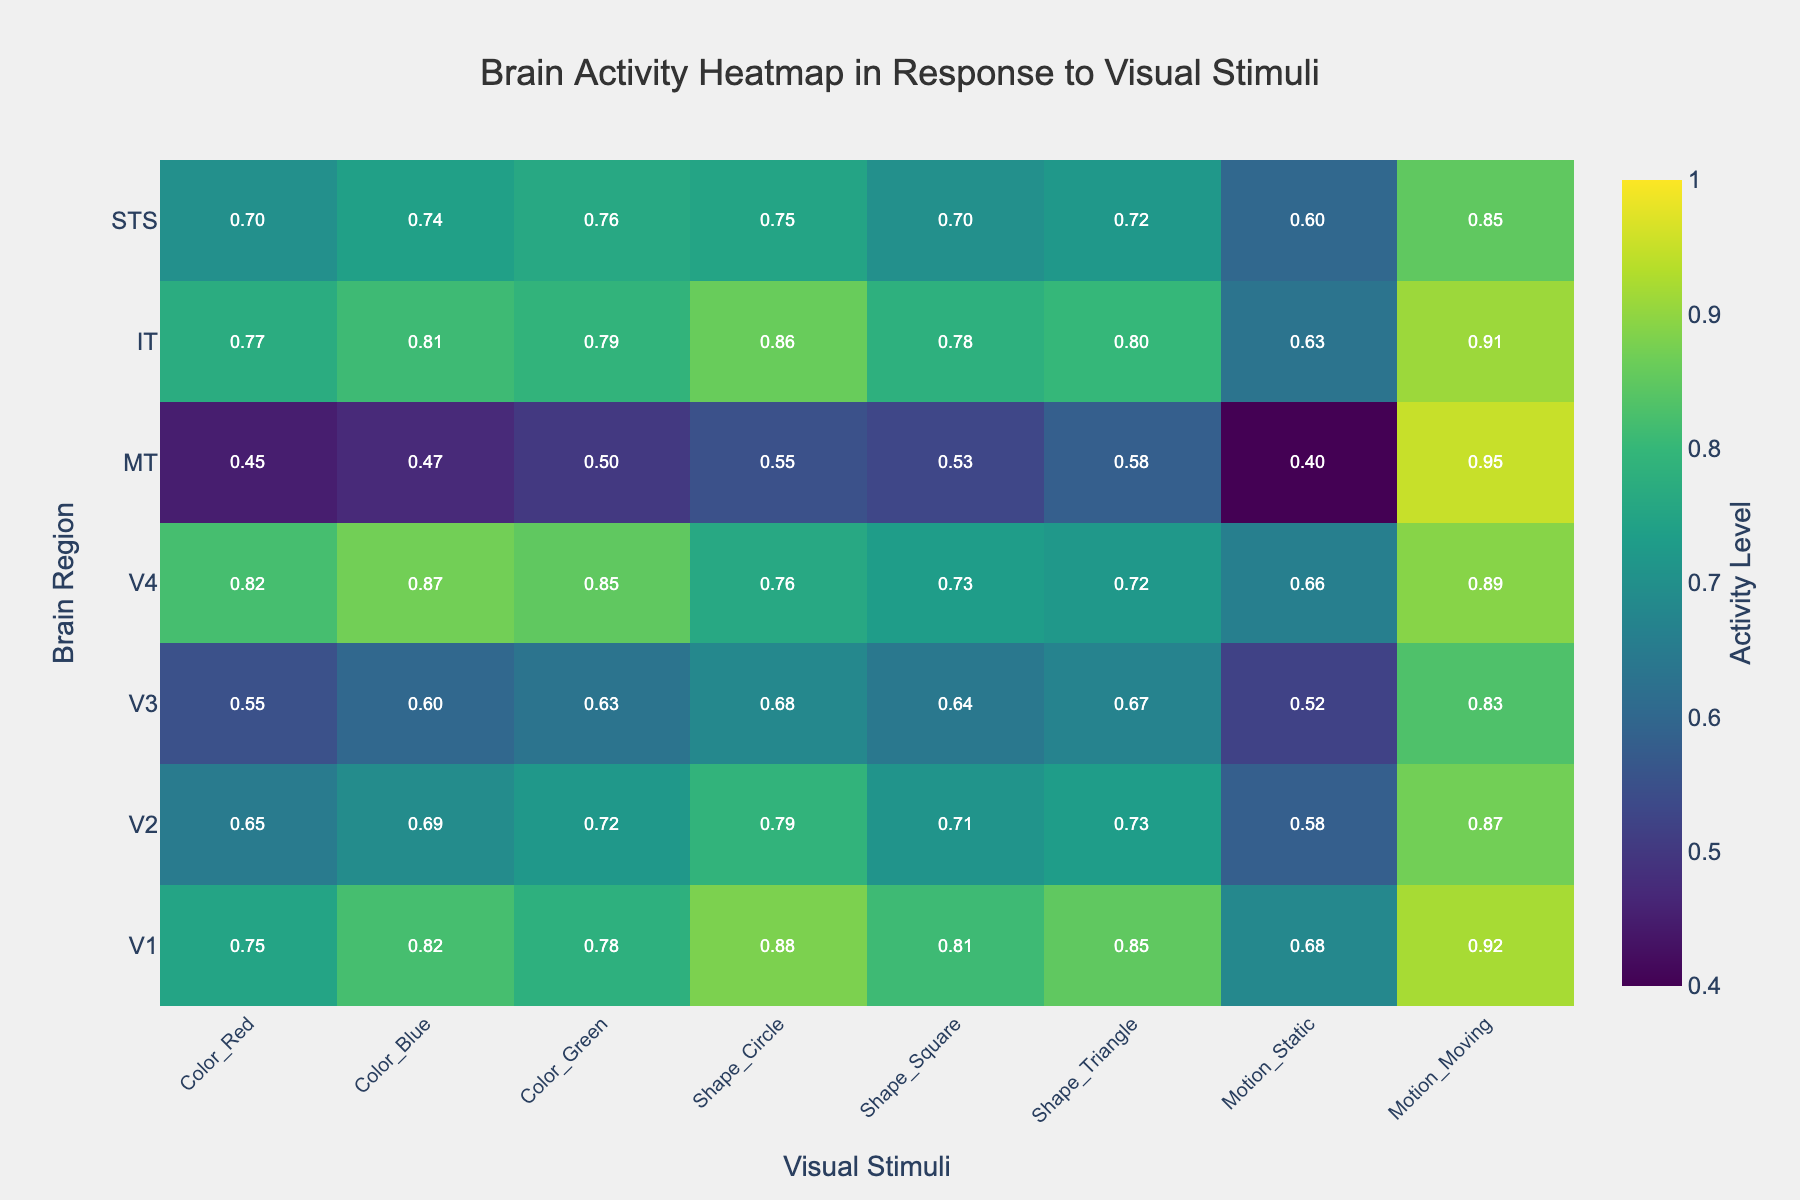What is the highest brain activity level recorded for the Motion_Moving stimulus? To find the highest brain activity level for the Motion_Moving stimulus, I look under the Motion_Moving column and note the highest value. The highest value recorded is 0.95.
Answer: 0.95 Which brain region shows the lowest activity level for the Color_Red stimulus? Examine the Color_Red column to find the lowest value. The lowest value is in row MT, with a value of 0.45.
Answer: MT What is the overall activity level in region V1 across all stimuli? Sum the activity levels for V1 across all columns: 0.75 + 0.82 + 0.78 + 0.88 + 0.81 + 0.85 + 0.68 + 0.92 = 6.49.
Answer: 6.49 How does the activity level for Shape_Circle in region STS compare with the activity level for Shape_Circle in region V3? Check the values in the Shape_Circle column for STS and V3. STS has 0.75 and V3 has 0.68. Compare these values to see that STS has a higher activity level.
Answer: STS is higher Which stimulus category shows the most variation in activity levels across all brain regions? Look at the range of values within each stimulus category. Motion_Moving has the most variation, ranging from 0.83 to 0.95, whereas other categories have smaller ranges.
Answer: Motion_Moving What is the average activity level for visual stimuli related to shapes (Shape_Circle, Shape_Square, Shape_Triangle) in the IT region? Calculate the average of Shape_Circle, Shape_Square, and Shape_Triangle activity levels in IT: (0.86 + 0.78 + 0.80)/3 = 0.8133.
Answer: 0.8133 Which regions show higher activity levels for color stimuli (Color_Red, Color_Blue, Color_Green) than for motion stimuli (Motion_Static, Motion_Moving)? Compare the average activity levels for color stimuli and motion stimuli for each region. Regions V1, V2, and IT have higher activity levels for color stimuli compared to motion stimuli.
Answer: V1, V2, IT For the V4 region, what is the difference in activity levels between Shape_Circle and Motion_Moving stimuli? Subtract the activity level of Shape_Circle from Motion_Moving in V4: 0.89 - 0.76 = 0.13.
Answer: 0.13 Which regions have a higher response to moving motion compared to static motion? Compare the values in the Motion_Static and Motion_Moving columns for each region. Regions V1, V2, V3, V4, MT, IT, and STS all show higher activity for moving motion.
Answer: V1, V2, V3, V4, MT, IT, STS What is the most common range of activity levels across all stimuli? Observe the range of values across all stimuli. Most values fall between 0.68 and 0.85.
Answer: 0.68 to 0.85 